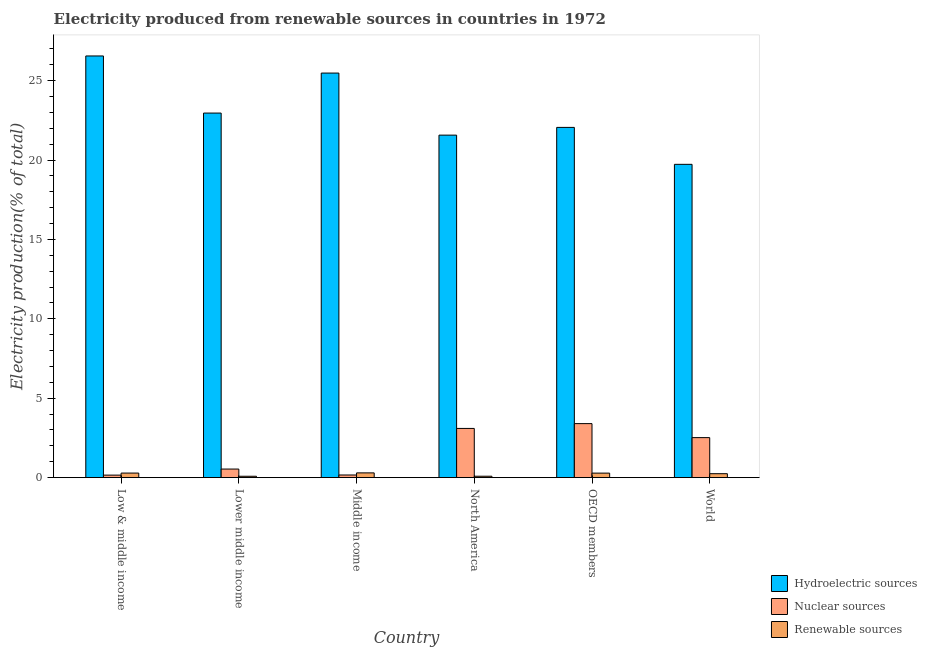How many different coloured bars are there?
Your answer should be compact. 3. How many groups of bars are there?
Make the answer very short. 6. How many bars are there on the 2nd tick from the left?
Give a very brief answer. 3. How many bars are there on the 6th tick from the right?
Provide a succinct answer. 3. What is the percentage of electricity produced by hydroelectric sources in World?
Ensure brevity in your answer.  19.73. Across all countries, what is the maximum percentage of electricity produced by hydroelectric sources?
Your answer should be very brief. 26.56. Across all countries, what is the minimum percentage of electricity produced by hydroelectric sources?
Keep it short and to the point. 19.73. In which country was the percentage of electricity produced by renewable sources minimum?
Provide a short and direct response. Lower middle income. What is the total percentage of electricity produced by nuclear sources in the graph?
Your answer should be very brief. 9.88. What is the difference between the percentage of electricity produced by nuclear sources in Middle income and that in North America?
Keep it short and to the point. -2.93. What is the difference between the percentage of electricity produced by renewable sources in Lower middle income and the percentage of electricity produced by hydroelectric sources in World?
Provide a succinct answer. -19.65. What is the average percentage of electricity produced by renewable sources per country?
Keep it short and to the point. 0.21. What is the difference between the percentage of electricity produced by hydroelectric sources and percentage of electricity produced by nuclear sources in Low & middle income?
Provide a short and direct response. 26.4. What is the ratio of the percentage of electricity produced by renewable sources in Lower middle income to that in World?
Provide a succinct answer. 0.35. Is the difference between the percentage of electricity produced by hydroelectric sources in Low & middle income and OECD members greater than the difference between the percentage of electricity produced by nuclear sources in Low & middle income and OECD members?
Make the answer very short. Yes. What is the difference between the highest and the second highest percentage of electricity produced by hydroelectric sources?
Ensure brevity in your answer.  1.08. What is the difference between the highest and the lowest percentage of electricity produced by nuclear sources?
Provide a short and direct response. 3.24. In how many countries, is the percentage of electricity produced by nuclear sources greater than the average percentage of electricity produced by nuclear sources taken over all countries?
Offer a terse response. 3. What does the 3rd bar from the left in World represents?
Ensure brevity in your answer.  Renewable sources. What does the 3rd bar from the right in Low & middle income represents?
Keep it short and to the point. Hydroelectric sources. Are all the bars in the graph horizontal?
Your response must be concise. No. What is the difference between two consecutive major ticks on the Y-axis?
Keep it short and to the point. 5. Are the values on the major ticks of Y-axis written in scientific E-notation?
Offer a terse response. No. Does the graph contain any zero values?
Offer a terse response. No. Does the graph contain grids?
Ensure brevity in your answer.  No. How are the legend labels stacked?
Your answer should be compact. Vertical. What is the title of the graph?
Offer a terse response. Electricity produced from renewable sources in countries in 1972. What is the label or title of the X-axis?
Provide a short and direct response. Country. What is the label or title of the Y-axis?
Keep it short and to the point. Electricity production(% of total). What is the Electricity production(% of total) in Hydroelectric sources in Low & middle income?
Ensure brevity in your answer.  26.56. What is the Electricity production(% of total) in Nuclear sources in Low & middle income?
Offer a terse response. 0.16. What is the Electricity production(% of total) of Renewable sources in Low & middle income?
Your answer should be very brief. 0.29. What is the Electricity production(% of total) of Hydroelectric sources in Lower middle income?
Your response must be concise. 22.96. What is the Electricity production(% of total) of Nuclear sources in Lower middle income?
Your answer should be compact. 0.54. What is the Electricity production(% of total) in Renewable sources in Lower middle income?
Offer a terse response. 0.09. What is the Electricity production(% of total) of Hydroelectric sources in Middle income?
Keep it short and to the point. 25.48. What is the Electricity production(% of total) in Nuclear sources in Middle income?
Provide a short and direct response. 0.17. What is the Electricity production(% of total) of Renewable sources in Middle income?
Ensure brevity in your answer.  0.3. What is the Electricity production(% of total) in Hydroelectric sources in North America?
Keep it short and to the point. 21.57. What is the Electricity production(% of total) of Nuclear sources in North America?
Make the answer very short. 3.1. What is the Electricity production(% of total) of Renewable sources in North America?
Offer a terse response. 0.09. What is the Electricity production(% of total) of Hydroelectric sources in OECD members?
Give a very brief answer. 22.06. What is the Electricity production(% of total) of Nuclear sources in OECD members?
Your answer should be compact. 3.4. What is the Electricity production(% of total) of Renewable sources in OECD members?
Your answer should be very brief. 0.28. What is the Electricity production(% of total) in Hydroelectric sources in World?
Provide a short and direct response. 19.73. What is the Electricity production(% of total) of Nuclear sources in World?
Your answer should be very brief. 2.52. What is the Electricity production(% of total) of Renewable sources in World?
Your response must be concise. 0.25. Across all countries, what is the maximum Electricity production(% of total) in Hydroelectric sources?
Your response must be concise. 26.56. Across all countries, what is the maximum Electricity production(% of total) in Nuclear sources?
Your answer should be compact. 3.4. Across all countries, what is the maximum Electricity production(% of total) in Renewable sources?
Your response must be concise. 0.3. Across all countries, what is the minimum Electricity production(% of total) of Hydroelectric sources?
Give a very brief answer. 19.73. Across all countries, what is the minimum Electricity production(% of total) in Nuclear sources?
Your answer should be very brief. 0.16. Across all countries, what is the minimum Electricity production(% of total) of Renewable sources?
Keep it short and to the point. 0.09. What is the total Electricity production(% of total) of Hydroelectric sources in the graph?
Offer a very short reply. 138.37. What is the total Electricity production(% of total) in Nuclear sources in the graph?
Provide a short and direct response. 9.88. What is the total Electricity production(% of total) of Renewable sources in the graph?
Provide a short and direct response. 1.29. What is the difference between the Electricity production(% of total) of Hydroelectric sources in Low & middle income and that in Lower middle income?
Ensure brevity in your answer.  3.6. What is the difference between the Electricity production(% of total) in Nuclear sources in Low & middle income and that in Lower middle income?
Give a very brief answer. -0.38. What is the difference between the Electricity production(% of total) of Renewable sources in Low & middle income and that in Lower middle income?
Give a very brief answer. 0.2. What is the difference between the Electricity production(% of total) in Hydroelectric sources in Low & middle income and that in Middle income?
Your answer should be very brief. 1.08. What is the difference between the Electricity production(% of total) of Nuclear sources in Low & middle income and that in Middle income?
Your answer should be very brief. -0.01. What is the difference between the Electricity production(% of total) of Renewable sources in Low & middle income and that in Middle income?
Provide a succinct answer. -0.01. What is the difference between the Electricity production(% of total) in Hydroelectric sources in Low & middle income and that in North America?
Your response must be concise. 4.99. What is the difference between the Electricity production(% of total) in Nuclear sources in Low & middle income and that in North America?
Ensure brevity in your answer.  -2.94. What is the difference between the Electricity production(% of total) of Renewable sources in Low & middle income and that in North America?
Your answer should be compact. 0.2. What is the difference between the Electricity production(% of total) of Hydroelectric sources in Low & middle income and that in OECD members?
Make the answer very short. 4.5. What is the difference between the Electricity production(% of total) of Nuclear sources in Low & middle income and that in OECD members?
Offer a terse response. -3.24. What is the difference between the Electricity production(% of total) in Renewable sources in Low & middle income and that in OECD members?
Make the answer very short. 0. What is the difference between the Electricity production(% of total) of Hydroelectric sources in Low & middle income and that in World?
Provide a short and direct response. 6.83. What is the difference between the Electricity production(% of total) of Nuclear sources in Low & middle income and that in World?
Make the answer very short. -2.36. What is the difference between the Electricity production(% of total) of Renewable sources in Low & middle income and that in World?
Make the answer very short. 0.04. What is the difference between the Electricity production(% of total) of Hydroelectric sources in Lower middle income and that in Middle income?
Provide a short and direct response. -2.52. What is the difference between the Electricity production(% of total) in Nuclear sources in Lower middle income and that in Middle income?
Your answer should be compact. 0.37. What is the difference between the Electricity production(% of total) in Renewable sources in Lower middle income and that in Middle income?
Keep it short and to the point. -0.21. What is the difference between the Electricity production(% of total) of Hydroelectric sources in Lower middle income and that in North America?
Your answer should be very brief. 1.39. What is the difference between the Electricity production(% of total) of Nuclear sources in Lower middle income and that in North America?
Your response must be concise. -2.56. What is the difference between the Electricity production(% of total) in Renewable sources in Lower middle income and that in North America?
Your answer should be very brief. -0. What is the difference between the Electricity production(% of total) in Hydroelectric sources in Lower middle income and that in OECD members?
Provide a short and direct response. 0.9. What is the difference between the Electricity production(% of total) in Nuclear sources in Lower middle income and that in OECD members?
Your response must be concise. -2.86. What is the difference between the Electricity production(% of total) in Renewable sources in Lower middle income and that in OECD members?
Your answer should be very brief. -0.2. What is the difference between the Electricity production(% of total) in Hydroelectric sources in Lower middle income and that in World?
Your response must be concise. 3.23. What is the difference between the Electricity production(% of total) of Nuclear sources in Lower middle income and that in World?
Keep it short and to the point. -1.98. What is the difference between the Electricity production(% of total) in Renewable sources in Lower middle income and that in World?
Your response must be concise. -0.16. What is the difference between the Electricity production(% of total) in Hydroelectric sources in Middle income and that in North America?
Offer a very short reply. 3.91. What is the difference between the Electricity production(% of total) of Nuclear sources in Middle income and that in North America?
Provide a succinct answer. -2.93. What is the difference between the Electricity production(% of total) in Renewable sources in Middle income and that in North America?
Give a very brief answer. 0.21. What is the difference between the Electricity production(% of total) of Hydroelectric sources in Middle income and that in OECD members?
Provide a succinct answer. 3.42. What is the difference between the Electricity production(% of total) in Nuclear sources in Middle income and that in OECD members?
Keep it short and to the point. -3.24. What is the difference between the Electricity production(% of total) in Renewable sources in Middle income and that in OECD members?
Provide a succinct answer. 0.01. What is the difference between the Electricity production(% of total) of Hydroelectric sources in Middle income and that in World?
Your answer should be very brief. 5.75. What is the difference between the Electricity production(% of total) in Nuclear sources in Middle income and that in World?
Keep it short and to the point. -2.35. What is the difference between the Electricity production(% of total) of Renewable sources in Middle income and that in World?
Provide a short and direct response. 0.05. What is the difference between the Electricity production(% of total) in Hydroelectric sources in North America and that in OECD members?
Your answer should be very brief. -0.49. What is the difference between the Electricity production(% of total) of Nuclear sources in North America and that in OECD members?
Make the answer very short. -0.3. What is the difference between the Electricity production(% of total) in Renewable sources in North America and that in OECD members?
Provide a succinct answer. -0.2. What is the difference between the Electricity production(% of total) in Hydroelectric sources in North America and that in World?
Your response must be concise. 1.84. What is the difference between the Electricity production(% of total) in Nuclear sources in North America and that in World?
Your response must be concise. 0.58. What is the difference between the Electricity production(% of total) of Renewable sources in North America and that in World?
Give a very brief answer. -0.16. What is the difference between the Electricity production(% of total) in Hydroelectric sources in OECD members and that in World?
Offer a very short reply. 2.33. What is the difference between the Electricity production(% of total) in Nuclear sources in OECD members and that in World?
Give a very brief answer. 0.88. What is the difference between the Electricity production(% of total) of Renewable sources in OECD members and that in World?
Offer a terse response. 0.04. What is the difference between the Electricity production(% of total) in Hydroelectric sources in Low & middle income and the Electricity production(% of total) in Nuclear sources in Lower middle income?
Ensure brevity in your answer.  26.02. What is the difference between the Electricity production(% of total) in Hydroelectric sources in Low & middle income and the Electricity production(% of total) in Renewable sources in Lower middle income?
Give a very brief answer. 26.47. What is the difference between the Electricity production(% of total) in Nuclear sources in Low & middle income and the Electricity production(% of total) in Renewable sources in Lower middle income?
Provide a succinct answer. 0.07. What is the difference between the Electricity production(% of total) in Hydroelectric sources in Low & middle income and the Electricity production(% of total) in Nuclear sources in Middle income?
Offer a terse response. 26.39. What is the difference between the Electricity production(% of total) in Hydroelectric sources in Low & middle income and the Electricity production(% of total) in Renewable sources in Middle income?
Provide a succinct answer. 26.26. What is the difference between the Electricity production(% of total) in Nuclear sources in Low & middle income and the Electricity production(% of total) in Renewable sources in Middle income?
Give a very brief answer. -0.14. What is the difference between the Electricity production(% of total) in Hydroelectric sources in Low & middle income and the Electricity production(% of total) in Nuclear sources in North America?
Your answer should be very brief. 23.46. What is the difference between the Electricity production(% of total) of Hydroelectric sources in Low & middle income and the Electricity production(% of total) of Renewable sources in North America?
Keep it short and to the point. 26.47. What is the difference between the Electricity production(% of total) of Nuclear sources in Low & middle income and the Electricity production(% of total) of Renewable sources in North America?
Provide a succinct answer. 0.07. What is the difference between the Electricity production(% of total) of Hydroelectric sources in Low & middle income and the Electricity production(% of total) of Nuclear sources in OECD members?
Keep it short and to the point. 23.16. What is the difference between the Electricity production(% of total) of Hydroelectric sources in Low & middle income and the Electricity production(% of total) of Renewable sources in OECD members?
Keep it short and to the point. 26.28. What is the difference between the Electricity production(% of total) of Nuclear sources in Low & middle income and the Electricity production(% of total) of Renewable sources in OECD members?
Make the answer very short. -0.13. What is the difference between the Electricity production(% of total) of Hydroelectric sources in Low & middle income and the Electricity production(% of total) of Nuclear sources in World?
Make the answer very short. 24.04. What is the difference between the Electricity production(% of total) in Hydroelectric sources in Low & middle income and the Electricity production(% of total) in Renewable sources in World?
Provide a short and direct response. 26.31. What is the difference between the Electricity production(% of total) in Nuclear sources in Low & middle income and the Electricity production(% of total) in Renewable sources in World?
Your response must be concise. -0.09. What is the difference between the Electricity production(% of total) in Hydroelectric sources in Lower middle income and the Electricity production(% of total) in Nuclear sources in Middle income?
Offer a terse response. 22.8. What is the difference between the Electricity production(% of total) in Hydroelectric sources in Lower middle income and the Electricity production(% of total) in Renewable sources in Middle income?
Provide a short and direct response. 22.66. What is the difference between the Electricity production(% of total) of Nuclear sources in Lower middle income and the Electricity production(% of total) of Renewable sources in Middle income?
Your answer should be compact. 0.24. What is the difference between the Electricity production(% of total) of Hydroelectric sources in Lower middle income and the Electricity production(% of total) of Nuclear sources in North America?
Your answer should be compact. 19.86. What is the difference between the Electricity production(% of total) in Hydroelectric sources in Lower middle income and the Electricity production(% of total) in Renewable sources in North America?
Keep it short and to the point. 22.88. What is the difference between the Electricity production(% of total) of Nuclear sources in Lower middle income and the Electricity production(% of total) of Renewable sources in North America?
Provide a short and direct response. 0.45. What is the difference between the Electricity production(% of total) in Hydroelectric sources in Lower middle income and the Electricity production(% of total) in Nuclear sources in OECD members?
Make the answer very short. 19.56. What is the difference between the Electricity production(% of total) in Hydroelectric sources in Lower middle income and the Electricity production(% of total) in Renewable sources in OECD members?
Your answer should be compact. 22.68. What is the difference between the Electricity production(% of total) of Nuclear sources in Lower middle income and the Electricity production(% of total) of Renewable sources in OECD members?
Ensure brevity in your answer.  0.26. What is the difference between the Electricity production(% of total) in Hydroelectric sources in Lower middle income and the Electricity production(% of total) in Nuclear sources in World?
Offer a terse response. 20.44. What is the difference between the Electricity production(% of total) in Hydroelectric sources in Lower middle income and the Electricity production(% of total) in Renewable sources in World?
Offer a terse response. 22.72. What is the difference between the Electricity production(% of total) of Nuclear sources in Lower middle income and the Electricity production(% of total) of Renewable sources in World?
Offer a terse response. 0.29. What is the difference between the Electricity production(% of total) of Hydroelectric sources in Middle income and the Electricity production(% of total) of Nuclear sources in North America?
Your answer should be very brief. 22.38. What is the difference between the Electricity production(% of total) of Hydroelectric sources in Middle income and the Electricity production(% of total) of Renewable sources in North America?
Provide a short and direct response. 25.39. What is the difference between the Electricity production(% of total) in Nuclear sources in Middle income and the Electricity production(% of total) in Renewable sources in North America?
Your response must be concise. 0.08. What is the difference between the Electricity production(% of total) of Hydroelectric sources in Middle income and the Electricity production(% of total) of Nuclear sources in OECD members?
Ensure brevity in your answer.  22.08. What is the difference between the Electricity production(% of total) of Hydroelectric sources in Middle income and the Electricity production(% of total) of Renewable sources in OECD members?
Offer a terse response. 25.2. What is the difference between the Electricity production(% of total) in Nuclear sources in Middle income and the Electricity production(% of total) in Renewable sources in OECD members?
Make the answer very short. -0.12. What is the difference between the Electricity production(% of total) of Hydroelectric sources in Middle income and the Electricity production(% of total) of Nuclear sources in World?
Your response must be concise. 22.96. What is the difference between the Electricity production(% of total) in Hydroelectric sources in Middle income and the Electricity production(% of total) in Renewable sources in World?
Make the answer very short. 25.24. What is the difference between the Electricity production(% of total) of Nuclear sources in Middle income and the Electricity production(% of total) of Renewable sources in World?
Provide a short and direct response. -0.08. What is the difference between the Electricity production(% of total) in Hydroelectric sources in North America and the Electricity production(% of total) in Nuclear sources in OECD members?
Provide a short and direct response. 18.17. What is the difference between the Electricity production(% of total) in Hydroelectric sources in North America and the Electricity production(% of total) in Renewable sources in OECD members?
Ensure brevity in your answer.  21.29. What is the difference between the Electricity production(% of total) of Nuclear sources in North America and the Electricity production(% of total) of Renewable sources in OECD members?
Give a very brief answer. 2.81. What is the difference between the Electricity production(% of total) in Hydroelectric sources in North America and the Electricity production(% of total) in Nuclear sources in World?
Provide a succinct answer. 19.05. What is the difference between the Electricity production(% of total) in Hydroelectric sources in North America and the Electricity production(% of total) in Renewable sources in World?
Keep it short and to the point. 21.33. What is the difference between the Electricity production(% of total) of Nuclear sources in North America and the Electricity production(% of total) of Renewable sources in World?
Offer a terse response. 2.85. What is the difference between the Electricity production(% of total) of Hydroelectric sources in OECD members and the Electricity production(% of total) of Nuclear sources in World?
Your answer should be very brief. 19.54. What is the difference between the Electricity production(% of total) in Hydroelectric sources in OECD members and the Electricity production(% of total) in Renewable sources in World?
Provide a succinct answer. 21.81. What is the difference between the Electricity production(% of total) of Nuclear sources in OECD members and the Electricity production(% of total) of Renewable sources in World?
Your response must be concise. 3.15. What is the average Electricity production(% of total) of Hydroelectric sources per country?
Provide a short and direct response. 23.06. What is the average Electricity production(% of total) of Nuclear sources per country?
Your response must be concise. 1.65. What is the average Electricity production(% of total) of Renewable sources per country?
Offer a terse response. 0.21. What is the difference between the Electricity production(% of total) in Hydroelectric sources and Electricity production(% of total) in Nuclear sources in Low & middle income?
Your answer should be very brief. 26.4. What is the difference between the Electricity production(% of total) in Hydroelectric sources and Electricity production(% of total) in Renewable sources in Low & middle income?
Ensure brevity in your answer.  26.27. What is the difference between the Electricity production(% of total) of Nuclear sources and Electricity production(% of total) of Renewable sources in Low & middle income?
Your answer should be very brief. -0.13. What is the difference between the Electricity production(% of total) of Hydroelectric sources and Electricity production(% of total) of Nuclear sources in Lower middle income?
Provide a short and direct response. 22.42. What is the difference between the Electricity production(% of total) of Hydroelectric sources and Electricity production(% of total) of Renewable sources in Lower middle income?
Offer a very short reply. 22.88. What is the difference between the Electricity production(% of total) of Nuclear sources and Electricity production(% of total) of Renewable sources in Lower middle income?
Your response must be concise. 0.45. What is the difference between the Electricity production(% of total) of Hydroelectric sources and Electricity production(% of total) of Nuclear sources in Middle income?
Make the answer very short. 25.32. What is the difference between the Electricity production(% of total) of Hydroelectric sources and Electricity production(% of total) of Renewable sources in Middle income?
Ensure brevity in your answer.  25.18. What is the difference between the Electricity production(% of total) in Nuclear sources and Electricity production(% of total) in Renewable sources in Middle income?
Provide a succinct answer. -0.13. What is the difference between the Electricity production(% of total) of Hydroelectric sources and Electricity production(% of total) of Nuclear sources in North America?
Your answer should be very brief. 18.47. What is the difference between the Electricity production(% of total) of Hydroelectric sources and Electricity production(% of total) of Renewable sources in North America?
Keep it short and to the point. 21.49. What is the difference between the Electricity production(% of total) of Nuclear sources and Electricity production(% of total) of Renewable sources in North America?
Provide a succinct answer. 3.01. What is the difference between the Electricity production(% of total) in Hydroelectric sources and Electricity production(% of total) in Nuclear sources in OECD members?
Provide a succinct answer. 18.66. What is the difference between the Electricity production(% of total) of Hydroelectric sources and Electricity production(% of total) of Renewable sources in OECD members?
Ensure brevity in your answer.  21.78. What is the difference between the Electricity production(% of total) in Nuclear sources and Electricity production(% of total) in Renewable sources in OECD members?
Give a very brief answer. 3.12. What is the difference between the Electricity production(% of total) in Hydroelectric sources and Electricity production(% of total) in Nuclear sources in World?
Offer a terse response. 17.21. What is the difference between the Electricity production(% of total) of Hydroelectric sources and Electricity production(% of total) of Renewable sources in World?
Keep it short and to the point. 19.49. What is the difference between the Electricity production(% of total) in Nuclear sources and Electricity production(% of total) in Renewable sources in World?
Keep it short and to the point. 2.27. What is the ratio of the Electricity production(% of total) in Hydroelectric sources in Low & middle income to that in Lower middle income?
Provide a succinct answer. 1.16. What is the ratio of the Electricity production(% of total) of Nuclear sources in Low & middle income to that in Lower middle income?
Your response must be concise. 0.29. What is the ratio of the Electricity production(% of total) in Renewable sources in Low & middle income to that in Lower middle income?
Provide a short and direct response. 3.33. What is the ratio of the Electricity production(% of total) in Hydroelectric sources in Low & middle income to that in Middle income?
Make the answer very short. 1.04. What is the ratio of the Electricity production(% of total) in Nuclear sources in Low & middle income to that in Middle income?
Offer a very short reply. 0.95. What is the ratio of the Electricity production(% of total) in Hydroelectric sources in Low & middle income to that in North America?
Provide a short and direct response. 1.23. What is the ratio of the Electricity production(% of total) in Nuclear sources in Low & middle income to that in North America?
Ensure brevity in your answer.  0.05. What is the ratio of the Electricity production(% of total) of Renewable sources in Low & middle income to that in North America?
Make the answer very short. 3.27. What is the ratio of the Electricity production(% of total) of Hydroelectric sources in Low & middle income to that in OECD members?
Keep it short and to the point. 1.2. What is the ratio of the Electricity production(% of total) of Nuclear sources in Low & middle income to that in OECD members?
Make the answer very short. 0.05. What is the ratio of the Electricity production(% of total) in Hydroelectric sources in Low & middle income to that in World?
Offer a very short reply. 1.35. What is the ratio of the Electricity production(% of total) in Nuclear sources in Low & middle income to that in World?
Your answer should be very brief. 0.06. What is the ratio of the Electricity production(% of total) in Renewable sources in Low & middle income to that in World?
Your answer should be compact. 1.16. What is the ratio of the Electricity production(% of total) of Hydroelectric sources in Lower middle income to that in Middle income?
Keep it short and to the point. 0.9. What is the ratio of the Electricity production(% of total) in Nuclear sources in Lower middle income to that in Middle income?
Provide a short and direct response. 3.25. What is the ratio of the Electricity production(% of total) of Renewable sources in Lower middle income to that in Middle income?
Your answer should be very brief. 0.29. What is the ratio of the Electricity production(% of total) in Hydroelectric sources in Lower middle income to that in North America?
Offer a very short reply. 1.06. What is the ratio of the Electricity production(% of total) in Nuclear sources in Lower middle income to that in North America?
Your answer should be compact. 0.17. What is the ratio of the Electricity production(% of total) of Renewable sources in Lower middle income to that in North America?
Keep it short and to the point. 0.98. What is the ratio of the Electricity production(% of total) in Hydroelectric sources in Lower middle income to that in OECD members?
Your answer should be compact. 1.04. What is the ratio of the Electricity production(% of total) of Nuclear sources in Lower middle income to that in OECD members?
Ensure brevity in your answer.  0.16. What is the ratio of the Electricity production(% of total) of Renewable sources in Lower middle income to that in OECD members?
Make the answer very short. 0.3. What is the ratio of the Electricity production(% of total) of Hydroelectric sources in Lower middle income to that in World?
Offer a terse response. 1.16. What is the ratio of the Electricity production(% of total) of Nuclear sources in Lower middle income to that in World?
Make the answer very short. 0.21. What is the ratio of the Electricity production(% of total) of Renewable sources in Lower middle income to that in World?
Offer a very short reply. 0.35. What is the ratio of the Electricity production(% of total) of Hydroelectric sources in Middle income to that in North America?
Keep it short and to the point. 1.18. What is the ratio of the Electricity production(% of total) in Nuclear sources in Middle income to that in North America?
Your answer should be very brief. 0.05. What is the ratio of the Electricity production(% of total) of Renewable sources in Middle income to that in North America?
Offer a terse response. 3.41. What is the ratio of the Electricity production(% of total) in Hydroelectric sources in Middle income to that in OECD members?
Your response must be concise. 1.16. What is the ratio of the Electricity production(% of total) in Nuclear sources in Middle income to that in OECD members?
Keep it short and to the point. 0.05. What is the ratio of the Electricity production(% of total) of Renewable sources in Middle income to that in OECD members?
Provide a succinct answer. 1.05. What is the ratio of the Electricity production(% of total) in Hydroelectric sources in Middle income to that in World?
Your answer should be compact. 1.29. What is the ratio of the Electricity production(% of total) in Nuclear sources in Middle income to that in World?
Keep it short and to the point. 0.07. What is the ratio of the Electricity production(% of total) of Renewable sources in Middle income to that in World?
Offer a very short reply. 1.21. What is the ratio of the Electricity production(% of total) in Hydroelectric sources in North America to that in OECD members?
Offer a very short reply. 0.98. What is the ratio of the Electricity production(% of total) of Nuclear sources in North America to that in OECD members?
Offer a very short reply. 0.91. What is the ratio of the Electricity production(% of total) in Renewable sources in North America to that in OECD members?
Offer a terse response. 0.31. What is the ratio of the Electricity production(% of total) in Hydroelectric sources in North America to that in World?
Ensure brevity in your answer.  1.09. What is the ratio of the Electricity production(% of total) in Nuclear sources in North America to that in World?
Make the answer very short. 1.23. What is the ratio of the Electricity production(% of total) of Renewable sources in North America to that in World?
Provide a succinct answer. 0.35. What is the ratio of the Electricity production(% of total) in Hydroelectric sources in OECD members to that in World?
Your answer should be compact. 1.12. What is the ratio of the Electricity production(% of total) in Nuclear sources in OECD members to that in World?
Make the answer very short. 1.35. What is the ratio of the Electricity production(% of total) of Renewable sources in OECD members to that in World?
Make the answer very short. 1.15. What is the difference between the highest and the second highest Electricity production(% of total) in Hydroelectric sources?
Ensure brevity in your answer.  1.08. What is the difference between the highest and the second highest Electricity production(% of total) in Nuclear sources?
Provide a succinct answer. 0.3. What is the difference between the highest and the second highest Electricity production(% of total) in Renewable sources?
Keep it short and to the point. 0.01. What is the difference between the highest and the lowest Electricity production(% of total) of Hydroelectric sources?
Offer a very short reply. 6.83. What is the difference between the highest and the lowest Electricity production(% of total) of Nuclear sources?
Keep it short and to the point. 3.24. What is the difference between the highest and the lowest Electricity production(% of total) of Renewable sources?
Ensure brevity in your answer.  0.21. 